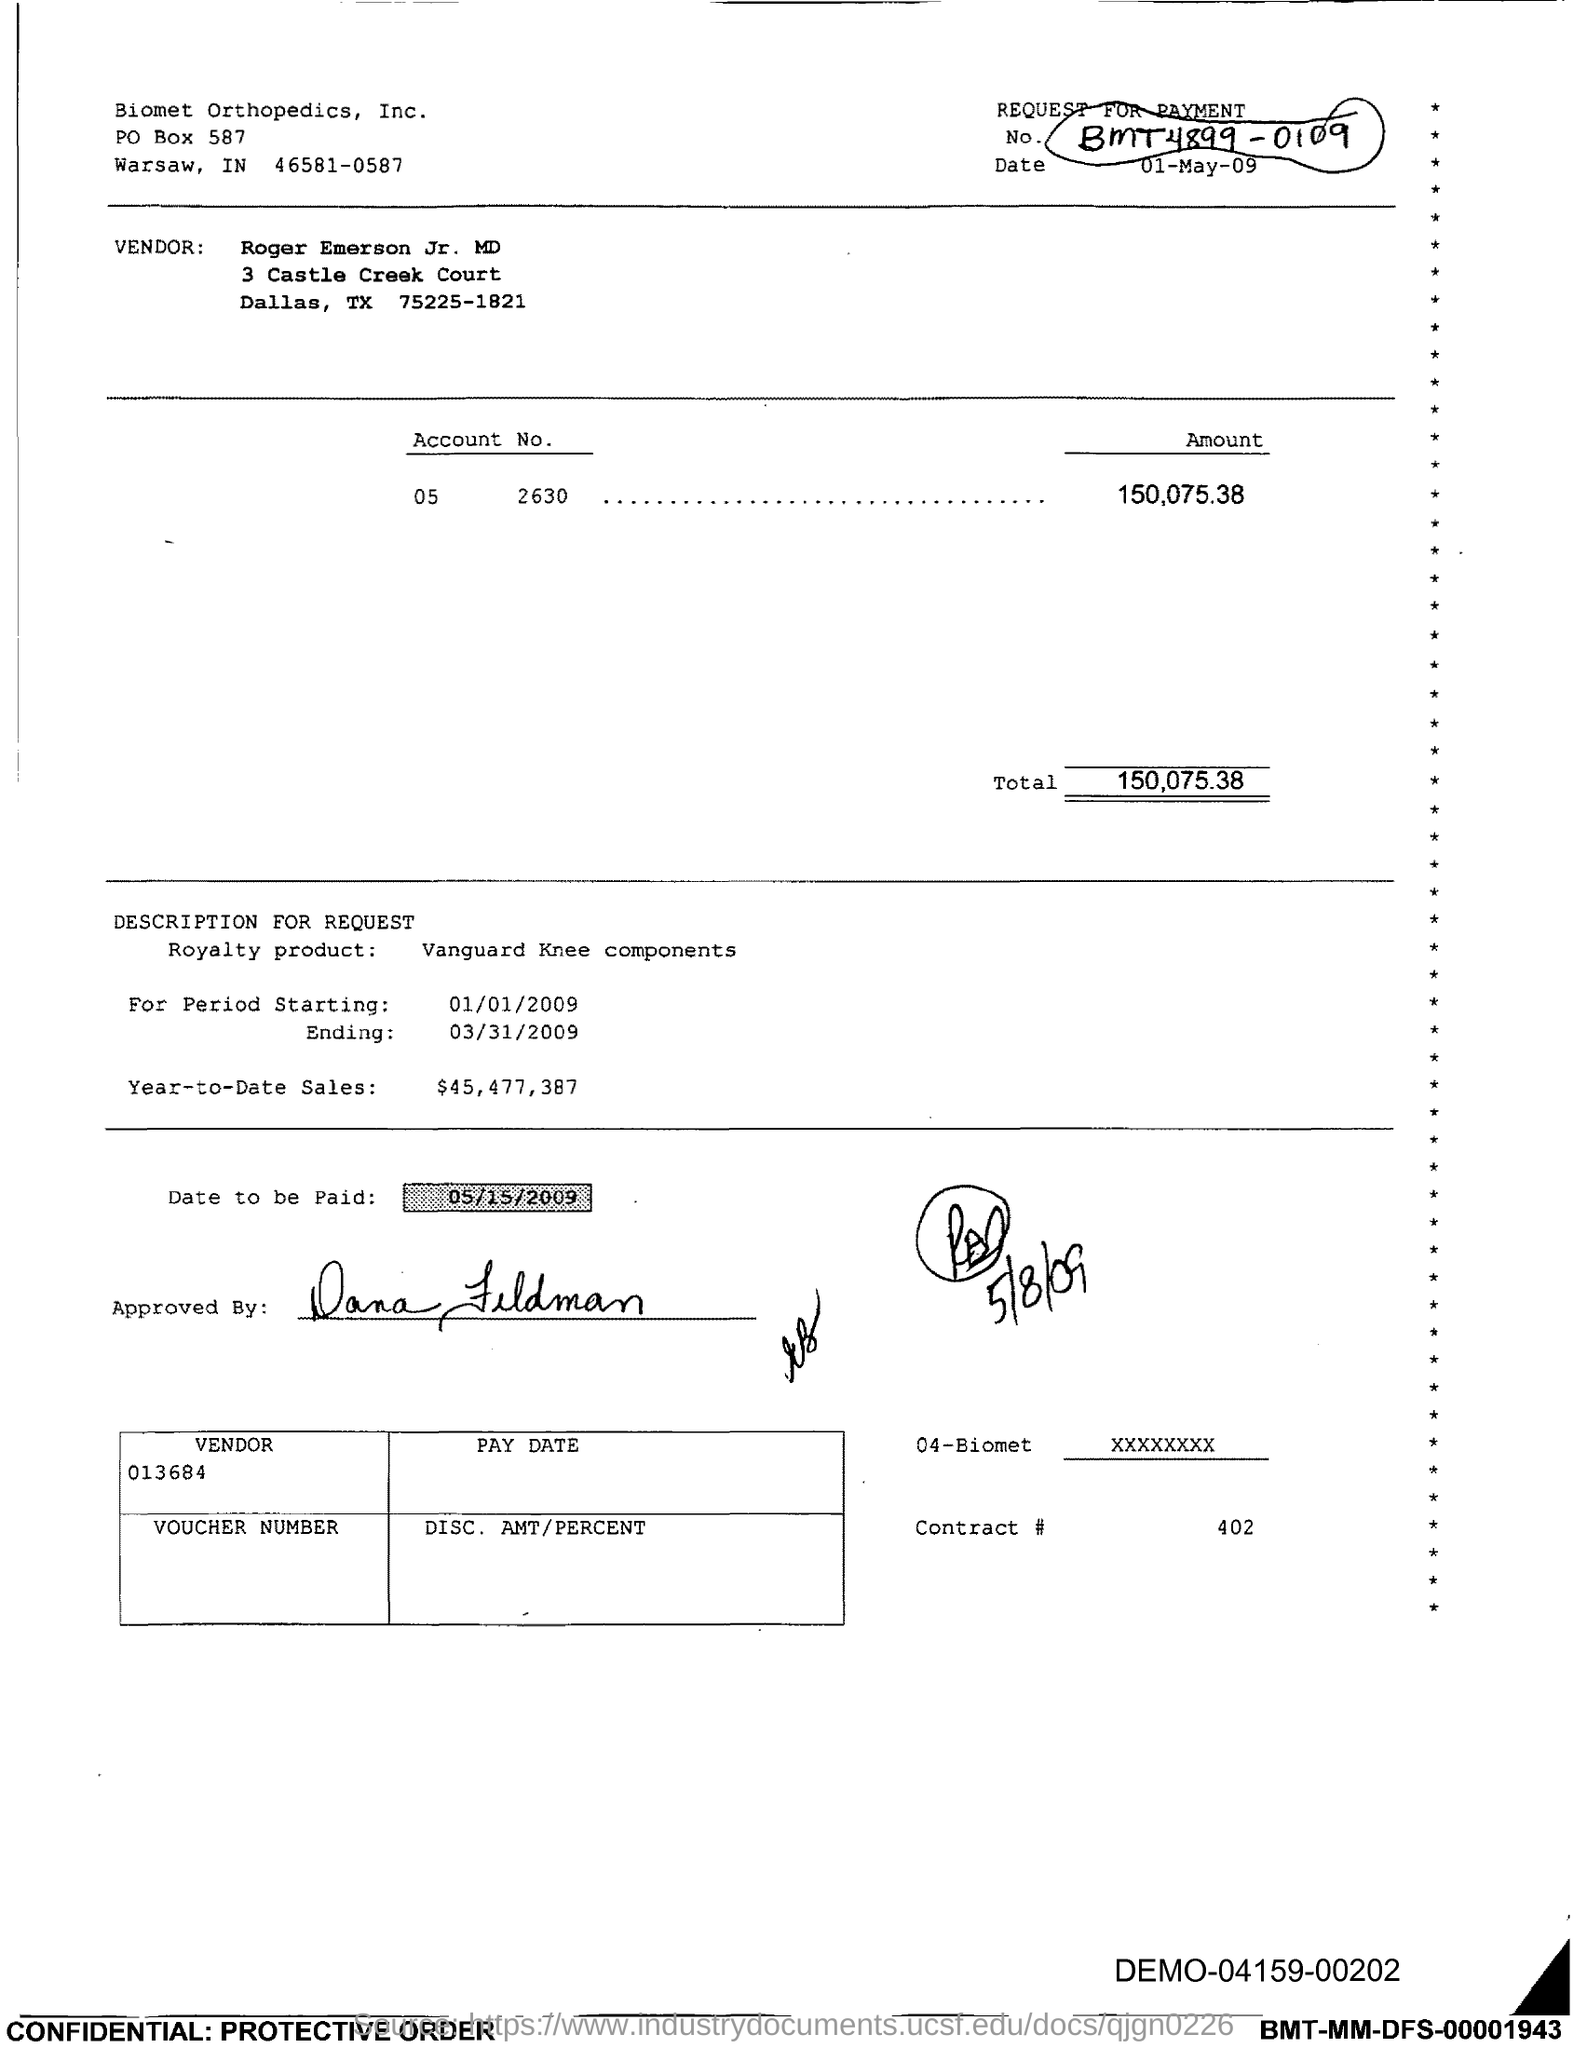What is the Contract # Number?
Provide a short and direct response. 402. What is the Total?
Offer a terse response. 150,075.38. 